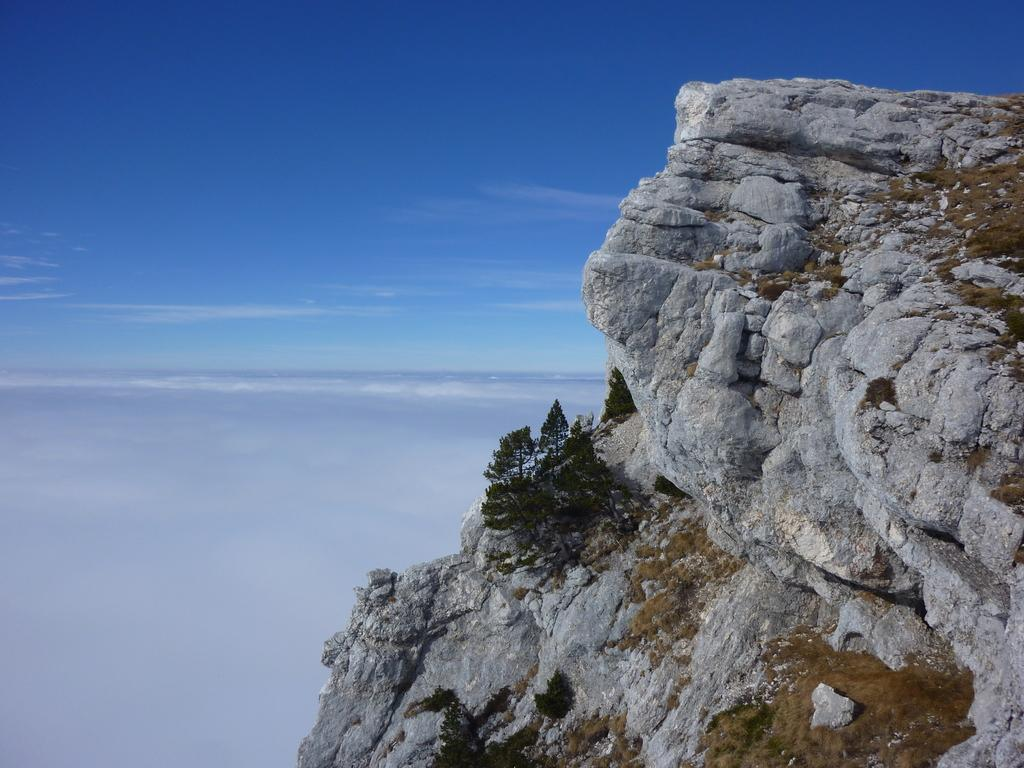What type of natural formation can be seen on the right side of the image? There are huge rocks in the image. What is growing on the rocks? Plants are present on the rocks. Where are the clouds and blue sky located in the image? The clouds and blue sky are on the left side of the image. What is the color of the sky in the image? The sky is blue and visible in the image. Can you see the tail of the animal on the rocks in the image? There is no animal or tail present in the image; it features huge rocks with plants on them. What type of badge is visible on the hill in the image? There is no hill or badge present in the image; it only features rocks, plants, clouds, and a blue sky. 